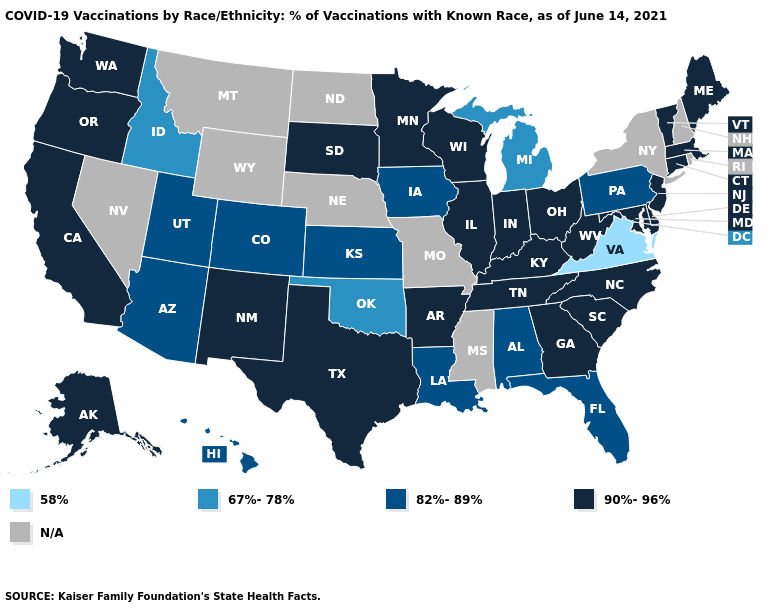How many symbols are there in the legend?
Give a very brief answer. 5. Which states have the highest value in the USA?
Concise answer only. Alaska, Arkansas, California, Connecticut, Delaware, Georgia, Illinois, Indiana, Kentucky, Maine, Maryland, Massachusetts, Minnesota, New Jersey, New Mexico, North Carolina, Ohio, Oregon, South Carolina, South Dakota, Tennessee, Texas, Vermont, Washington, West Virginia, Wisconsin. Name the states that have a value in the range 67%-78%?
Short answer required. Idaho, Michigan, Oklahoma. Does the first symbol in the legend represent the smallest category?
Answer briefly. Yes. Does Indiana have the lowest value in the USA?
Be succinct. No. Among the states that border Georgia , does South Carolina have the highest value?
Write a very short answer. Yes. Name the states that have a value in the range 82%-89%?
Write a very short answer. Alabama, Arizona, Colorado, Florida, Hawaii, Iowa, Kansas, Louisiana, Pennsylvania, Utah. Name the states that have a value in the range 67%-78%?
Concise answer only. Idaho, Michigan, Oklahoma. What is the value of Missouri?
Give a very brief answer. N/A. Name the states that have a value in the range 82%-89%?
Keep it brief. Alabama, Arizona, Colorado, Florida, Hawaii, Iowa, Kansas, Louisiana, Pennsylvania, Utah. Among the states that border Wisconsin , which have the highest value?
Concise answer only. Illinois, Minnesota. Does Iowa have the highest value in the MidWest?
Be succinct. No. What is the highest value in states that border North Carolina?
Write a very short answer. 90%-96%. Which states hav the highest value in the South?
Quick response, please. Arkansas, Delaware, Georgia, Kentucky, Maryland, North Carolina, South Carolina, Tennessee, Texas, West Virginia. 